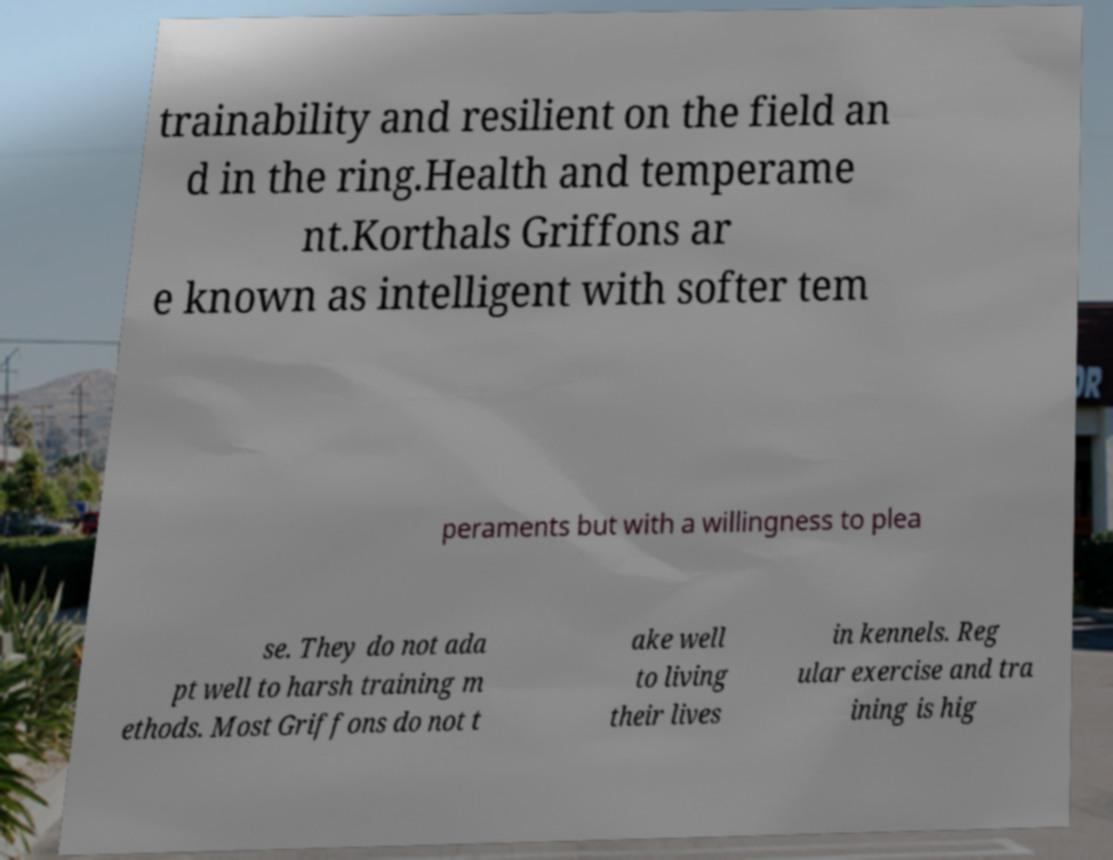I need the written content from this picture converted into text. Can you do that? trainability and resilient on the field an d in the ring.Health and temperame nt.Korthals Griffons ar e known as intelligent with softer tem peraments but with a willingness to plea se. They do not ada pt well to harsh training m ethods. Most Griffons do not t ake well to living their lives in kennels. Reg ular exercise and tra ining is hig 